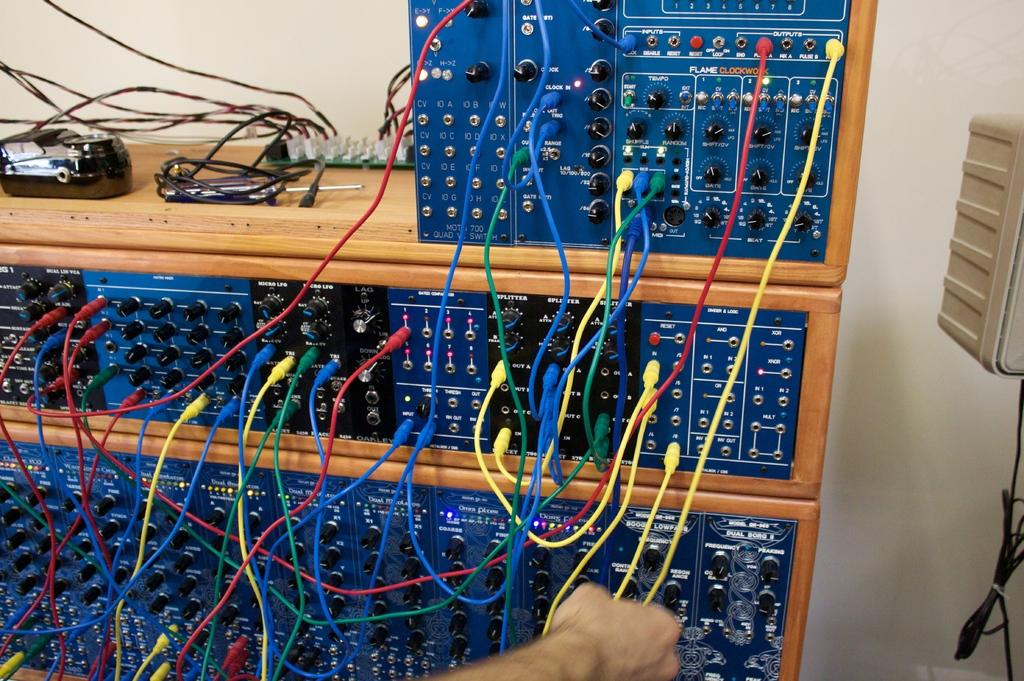What can be seen in the image related to electrical systems? There are electrical switch boards in the image. How are the switch boards organized or stored? The switch boards are arranged in a wooden cupboard. Is there anyone present in the image? Yes, there is a person in the image. What is the person holding in their hand? The person is holding a wire. What type of butter is being used to grease the switch boards in the image? There is no butter present in the image, and the switch boards are not being greased. 